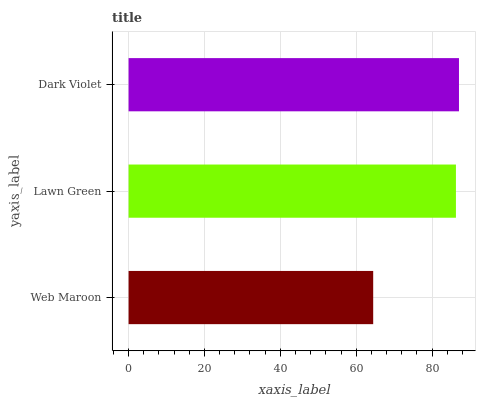Is Web Maroon the minimum?
Answer yes or no. Yes. Is Dark Violet the maximum?
Answer yes or no. Yes. Is Lawn Green the minimum?
Answer yes or no. No. Is Lawn Green the maximum?
Answer yes or no. No. Is Lawn Green greater than Web Maroon?
Answer yes or no. Yes. Is Web Maroon less than Lawn Green?
Answer yes or no. Yes. Is Web Maroon greater than Lawn Green?
Answer yes or no. No. Is Lawn Green less than Web Maroon?
Answer yes or no. No. Is Lawn Green the high median?
Answer yes or no. Yes. Is Lawn Green the low median?
Answer yes or no. Yes. Is Dark Violet the high median?
Answer yes or no. No. Is Dark Violet the low median?
Answer yes or no. No. 